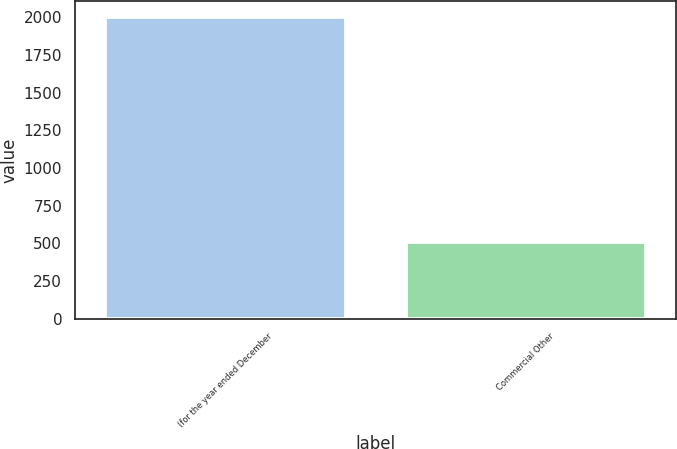Convert chart to OTSL. <chart><loc_0><loc_0><loc_500><loc_500><bar_chart><fcel>(for the year ended December<fcel>Commercial Other<nl><fcel>2004<fcel>506<nl></chart> 